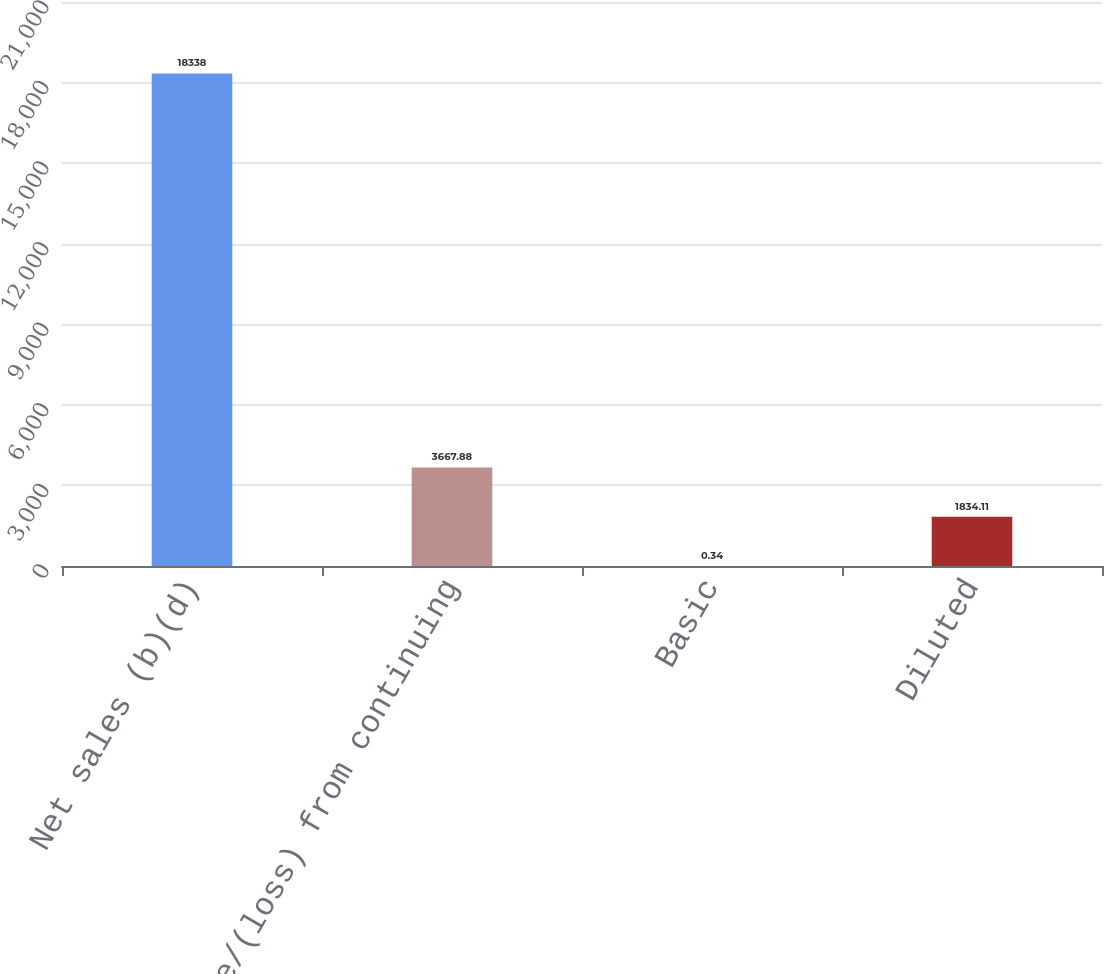Convert chart. <chart><loc_0><loc_0><loc_500><loc_500><bar_chart><fcel>Net sales (b)(d)<fcel>Income/(loss) from continuing<fcel>Basic<fcel>Diluted<nl><fcel>18338<fcel>3667.88<fcel>0.34<fcel>1834.11<nl></chart> 